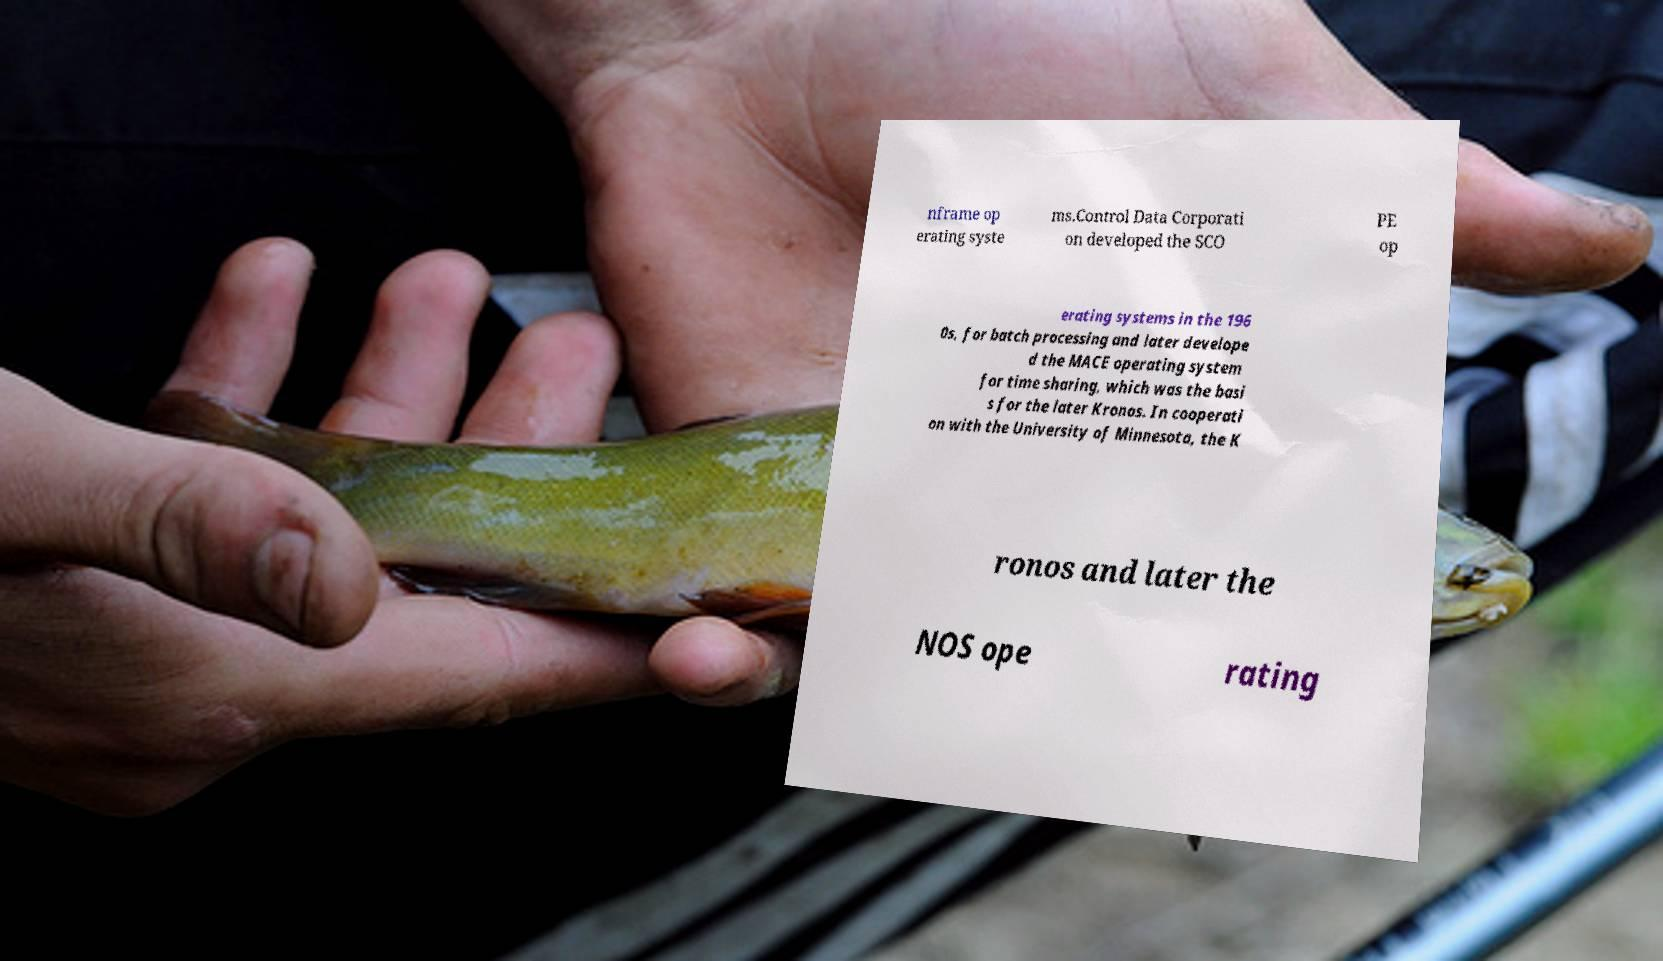Could you extract and type out the text from this image? nframe op erating syste ms.Control Data Corporati on developed the SCO PE op erating systems in the 196 0s, for batch processing and later develope d the MACE operating system for time sharing, which was the basi s for the later Kronos. In cooperati on with the University of Minnesota, the K ronos and later the NOS ope rating 